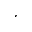Convert formula to latex. <formula><loc_0><loc_0><loc_500><loc_500>^ { , }</formula> 